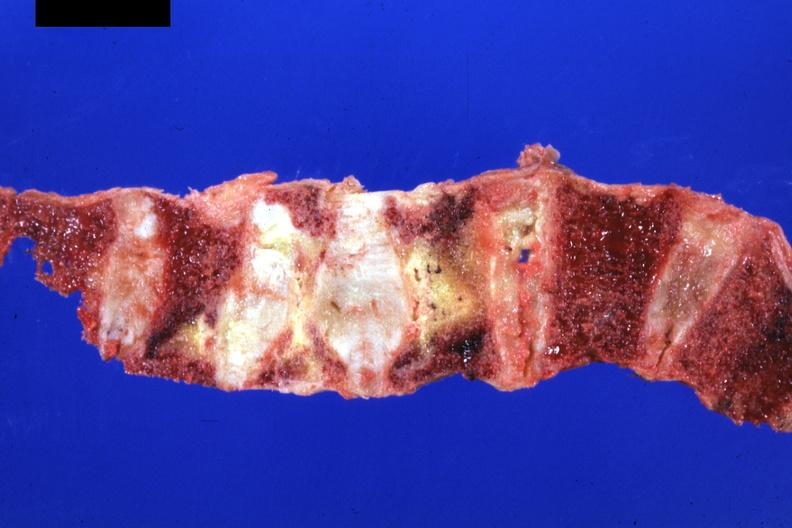s surface of nodes seen externally in slide present?
Answer the question using a single word or phrase. No 